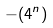Convert formula to latex. <formula><loc_0><loc_0><loc_500><loc_500>- ( 4 ^ { n } )</formula> 